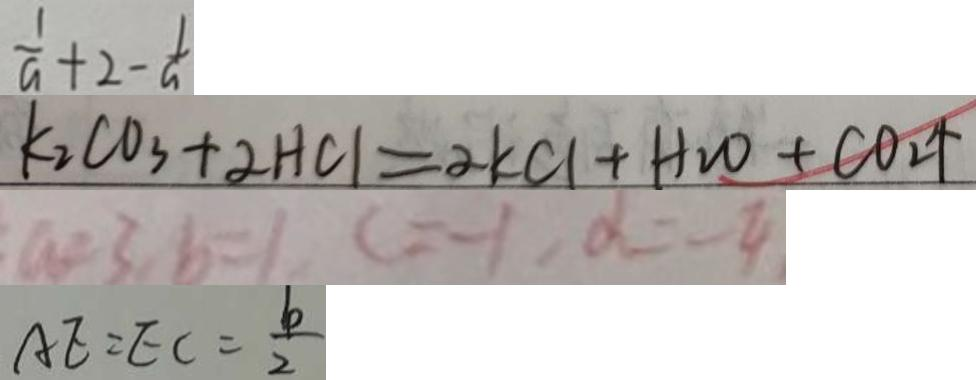<formula> <loc_0><loc_0><loc_500><loc_500>\frac { 1 } { a } + 2 - \frac { 1 } { a } 
 k _ { 2 } C O _ { 3 } + 2 H C l = 2 k C l + H _ { 2 } O + C O _ { 2 } \uparrow 
 a = 3 , b = 1 , c = - 1 , d = - 4 
 A E = E C = \frac { b } { 2 }</formula> 